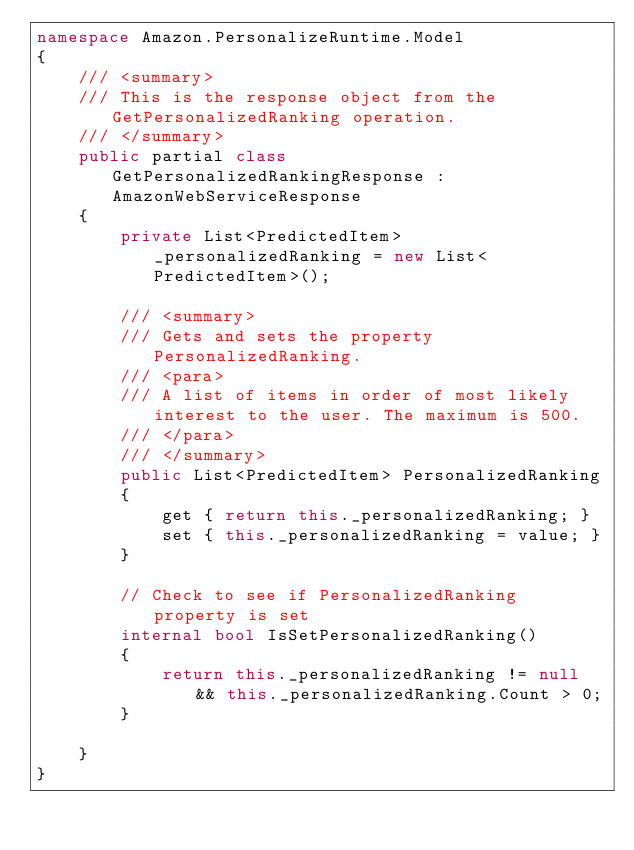<code> <loc_0><loc_0><loc_500><loc_500><_C#_>namespace Amazon.PersonalizeRuntime.Model
{
    /// <summary>
    /// This is the response object from the GetPersonalizedRanking operation.
    /// </summary>
    public partial class GetPersonalizedRankingResponse : AmazonWebServiceResponse
    {
        private List<PredictedItem> _personalizedRanking = new List<PredictedItem>();

        /// <summary>
        /// Gets and sets the property PersonalizedRanking. 
        /// <para>
        /// A list of items in order of most likely interest to the user. The maximum is 500.
        /// </para>
        /// </summary>
        public List<PredictedItem> PersonalizedRanking
        {
            get { return this._personalizedRanking; }
            set { this._personalizedRanking = value; }
        }

        // Check to see if PersonalizedRanking property is set
        internal bool IsSetPersonalizedRanking()
        {
            return this._personalizedRanking != null && this._personalizedRanking.Count > 0; 
        }

    }
}</code> 